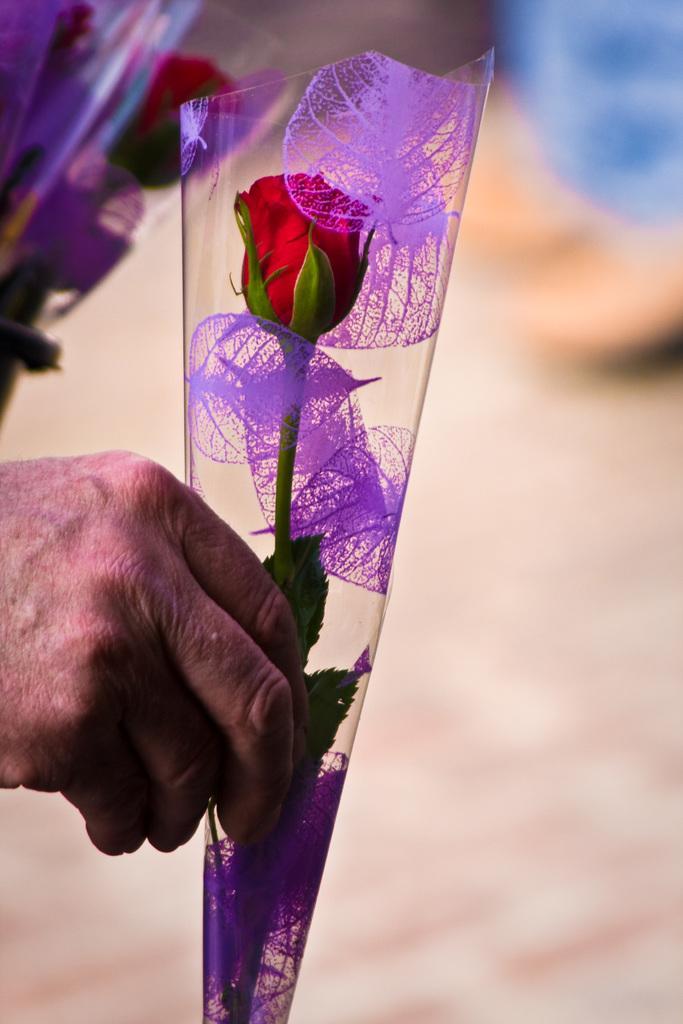Please provide a concise description of this image. In this picture we can see a person holding a red flower in a cover. There are few flowers in covers in the background. 